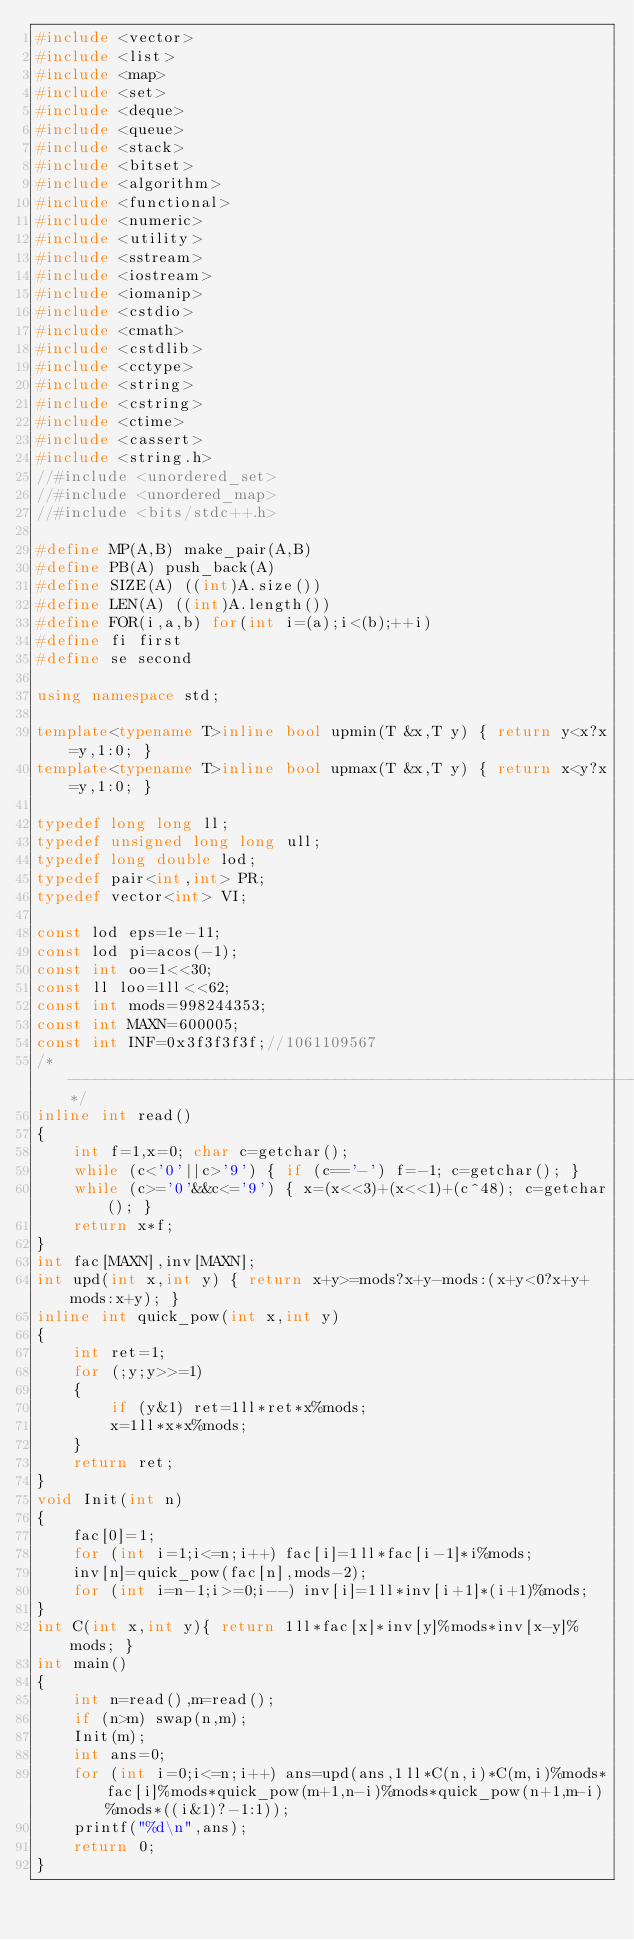Convert code to text. <code><loc_0><loc_0><loc_500><loc_500><_C++_>#include <vector>
#include <list>
#include <map>
#include <set>
#include <deque>
#include <queue>
#include <stack>
#include <bitset>
#include <algorithm>
#include <functional>
#include <numeric>
#include <utility>
#include <sstream>
#include <iostream>
#include <iomanip>
#include <cstdio>
#include <cmath>
#include <cstdlib>
#include <cctype>
#include <string>
#include <cstring>
#include <ctime>
#include <cassert>
#include <string.h>
//#include <unordered_set>
//#include <unordered_map>
//#include <bits/stdc++.h>

#define MP(A,B) make_pair(A,B)
#define PB(A) push_back(A)
#define SIZE(A) ((int)A.size())
#define LEN(A) ((int)A.length())
#define FOR(i,a,b) for(int i=(a);i<(b);++i)
#define fi first
#define se second

using namespace std;

template<typename T>inline bool upmin(T &x,T y) { return y<x?x=y,1:0; }
template<typename T>inline bool upmax(T &x,T y) { return x<y?x=y,1:0; }

typedef long long ll;
typedef unsigned long long ull;
typedef long double lod;
typedef pair<int,int> PR;
typedef vector<int> VI;

const lod eps=1e-11;
const lod pi=acos(-1);
const int oo=1<<30;
const ll loo=1ll<<62;
const int mods=998244353;
const int MAXN=600005;
const int INF=0x3f3f3f3f;//1061109567
/*--------------------------------------------------------------------*/
inline int read()
{
	int f=1,x=0; char c=getchar();
	while (c<'0'||c>'9') { if (c=='-') f=-1; c=getchar(); }
	while (c>='0'&&c<='9') { x=(x<<3)+(x<<1)+(c^48); c=getchar(); }
	return x*f;
}
int fac[MAXN],inv[MAXN];
int upd(int x,int y) { return x+y>=mods?x+y-mods:(x+y<0?x+y+mods:x+y); }
inline int quick_pow(int x,int y)
{
	int ret=1;
	for (;y;y>>=1)
	{
		if (y&1) ret=1ll*ret*x%mods;
		x=1ll*x*x%mods;
	}
	return ret;
}
void Init(int n)
{
	fac[0]=1;
	for (int i=1;i<=n;i++) fac[i]=1ll*fac[i-1]*i%mods;
	inv[n]=quick_pow(fac[n],mods-2);
	for (int i=n-1;i>=0;i--) inv[i]=1ll*inv[i+1]*(i+1)%mods;
}
int C(int x,int y){ return 1ll*fac[x]*inv[y]%mods*inv[x-y]%mods; }
int main()
{
	int n=read(),m=read();
	if (n>m) swap(n,m);
	Init(m);
	int ans=0;
	for (int i=0;i<=n;i++) ans=upd(ans,1ll*C(n,i)*C(m,i)%mods*fac[i]%mods*quick_pow(m+1,n-i)%mods*quick_pow(n+1,m-i)%mods*((i&1)?-1:1));
	printf("%d\n",ans);
	return 0;
}
</code> 